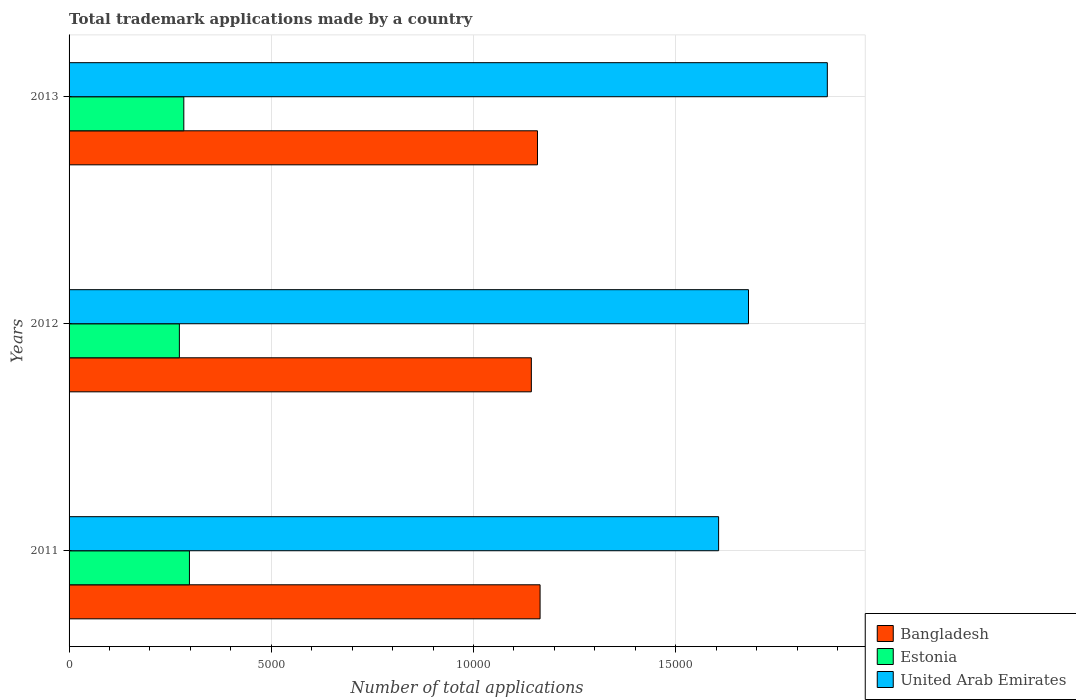How many different coloured bars are there?
Provide a succinct answer. 3. How many groups of bars are there?
Make the answer very short. 3. Are the number of bars on each tick of the Y-axis equal?
Offer a terse response. Yes. How many bars are there on the 3rd tick from the top?
Make the answer very short. 3. In how many cases, is the number of bars for a given year not equal to the number of legend labels?
Offer a very short reply. 0. What is the number of applications made by in Estonia in 2011?
Provide a succinct answer. 2976. Across all years, what is the maximum number of applications made by in Bangladesh?
Your answer should be very brief. 1.16e+04. Across all years, what is the minimum number of applications made by in United Arab Emirates?
Make the answer very short. 1.61e+04. In which year was the number of applications made by in United Arab Emirates maximum?
Your answer should be compact. 2013. In which year was the number of applications made by in Estonia minimum?
Provide a short and direct response. 2012. What is the total number of applications made by in Estonia in the graph?
Your response must be concise. 8540. What is the difference between the number of applications made by in Estonia in 2012 and that in 2013?
Provide a short and direct response. -110. What is the difference between the number of applications made by in United Arab Emirates in 2011 and the number of applications made by in Bangladesh in 2012?
Give a very brief answer. 4630. What is the average number of applications made by in Estonia per year?
Your answer should be very brief. 2846.67. In the year 2013, what is the difference between the number of applications made by in United Arab Emirates and number of applications made by in Estonia?
Offer a very short reply. 1.59e+04. What is the ratio of the number of applications made by in Estonia in 2012 to that in 2013?
Your answer should be very brief. 0.96. What is the difference between the highest and the second highest number of applications made by in Bangladesh?
Ensure brevity in your answer.  64. What is the difference between the highest and the lowest number of applications made by in United Arab Emirates?
Provide a succinct answer. 2688. In how many years, is the number of applications made by in Estonia greater than the average number of applications made by in Estonia taken over all years?
Provide a short and direct response. 1. How many bars are there?
Keep it short and to the point. 9. What is the difference between two consecutive major ticks on the X-axis?
Provide a succinct answer. 5000. Does the graph contain grids?
Give a very brief answer. Yes. How are the legend labels stacked?
Ensure brevity in your answer.  Vertical. What is the title of the graph?
Your answer should be compact. Total trademark applications made by a country. Does "Cabo Verde" appear as one of the legend labels in the graph?
Give a very brief answer. No. What is the label or title of the X-axis?
Ensure brevity in your answer.  Number of total applications. What is the label or title of the Y-axis?
Your answer should be very brief. Years. What is the Number of total applications of Bangladesh in 2011?
Ensure brevity in your answer.  1.16e+04. What is the Number of total applications of Estonia in 2011?
Give a very brief answer. 2976. What is the Number of total applications of United Arab Emirates in 2011?
Your answer should be compact. 1.61e+04. What is the Number of total applications in Bangladesh in 2012?
Offer a very short reply. 1.14e+04. What is the Number of total applications in Estonia in 2012?
Make the answer very short. 2727. What is the Number of total applications in United Arab Emirates in 2012?
Offer a very short reply. 1.68e+04. What is the Number of total applications in Bangladesh in 2013?
Your answer should be very brief. 1.16e+04. What is the Number of total applications of Estonia in 2013?
Provide a short and direct response. 2837. What is the Number of total applications of United Arab Emirates in 2013?
Your answer should be very brief. 1.87e+04. Across all years, what is the maximum Number of total applications in Bangladesh?
Give a very brief answer. 1.16e+04. Across all years, what is the maximum Number of total applications of Estonia?
Your answer should be very brief. 2976. Across all years, what is the maximum Number of total applications of United Arab Emirates?
Offer a very short reply. 1.87e+04. Across all years, what is the minimum Number of total applications in Bangladesh?
Offer a terse response. 1.14e+04. Across all years, what is the minimum Number of total applications in Estonia?
Provide a succinct answer. 2727. Across all years, what is the minimum Number of total applications of United Arab Emirates?
Your response must be concise. 1.61e+04. What is the total Number of total applications in Bangladesh in the graph?
Ensure brevity in your answer.  3.47e+04. What is the total Number of total applications in Estonia in the graph?
Provide a succinct answer. 8540. What is the total Number of total applications in United Arab Emirates in the graph?
Provide a short and direct response. 5.16e+04. What is the difference between the Number of total applications of Bangladesh in 2011 and that in 2012?
Make the answer very short. 216. What is the difference between the Number of total applications of Estonia in 2011 and that in 2012?
Make the answer very short. 249. What is the difference between the Number of total applications in United Arab Emirates in 2011 and that in 2012?
Offer a very short reply. -739. What is the difference between the Number of total applications in Bangladesh in 2011 and that in 2013?
Make the answer very short. 64. What is the difference between the Number of total applications of Estonia in 2011 and that in 2013?
Your answer should be compact. 139. What is the difference between the Number of total applications in United Arab Emirates in 2011 and that in 2013?
Ensure brevity in your answer.  -2688. What is the difference between the Number of total applications in Bangladesh in 2012 and that in 2013?
Provide a short and direct response. -152. What is the difference between the Number of total applications of Estonia in 2012 and that in 2013?
Keep it short and to the point. -110. What is the difference between the Number of total applications in United Arab Emirates in 2012 and that in 2013?
Offer a very short reply. -1949. What is the difference between the Number of total applications of Bangladesh in 2011 and the Number of total applications of Estonia in 2012?
Keep it short and to the point. 8918. What is the difference between the Number of total applications in Bangladesh in 2011 and the Number of total applications in United Arab Emirates in 2012?
Your response must be concise. -5153. What is the difference between the Number of total applications of Estonia in 2011 and the Number of total applications of United Arab Emirates in 2012?
Keep it short and to the point. -1.38e+04. What is the difference between the Number of total applications in Bangladesh in 2011 and the Number of total applications in Estonia in 2013?
Your response must be concise. 8808. What is the difference between the Number of total applications in Bangladesh in 2011 and the Number of total applications in United Arab Emirates in 2013?
Your answer should be very brief. -7102. What is the difference between the Number of total applications of Estonia in 2011 and the Number of total applications of United Arab Emirates in 2013?
Ensure brevity in your answer.  -1.58e+04. What is the difference between the Number of total applications of Bangladesh in 2012 and the Number of total applications of Estonia in 2013?
Offer a very short reply. 8592. What is the difference between the Number of total applications in Bangladesh in 2012 and the Number of total applications in United Arab Emirates in 2013?
Make the answer very short. -7318. What is the difference between the Number of total applications of Estonia in 2012 and the Number of total applications of United Arab Emirates in 2013?
Ensure brevity in your answer.  -1.60e+04. What is the average Number of total applications in Bangladesh per year?
Ensure brevity in your answer.  1.16e+04. What is the average Number of total applications in Estonia per year?
Offer a terse response. 2846.67. What is the average Number of total applications of United Arab Emirates per year?
Provide a short and direct response. 1.72e+04. In the year 2011, what is the difference between the Number of total applications in Bangladesh and Number of total applications in Estonia?
Keep it short and to the point. 8669. In the year 2011, what is the difference between the Number of total applications of Bangladesh and Number of total applications of United Arab Emirates?
Your response must be concise. -4414. In the year 2011, what is the difference between the Number of total applications of Estonia and Number of total applications of United Arab Emirates?
Make the answer very short. -1.31e+04. In the year 2012, what is the difference between the Number of total applications of Bangladesh and Number of total applications of Estonia?
Offer a terse response. 8702. In the year 2012, what is the difference between the Number of total applications in Bangladesh and Number of total applications in United Arab Emirates?
Your response must be concise. -5369. In the year 2012, what is the difference between the Number of total applications in Estonia and Number of total applications in United Arab Emirates?
Provide a succinct answer. -1.41e+04. In the year 2013, what is the difference between the Number of total applications of Bangladesh and Number of total applications of Estonia?
Keep it short and to the point. 8744. In the year 2013, what is the difference between the Number of total applications of Bangladesh and Number of total applications of United Arab Emirates?
Provide a succinct answer. -7166. In the year 2013, what is the difference between the Number of total applications in Estonia and Number of total applications in United Arab Emirates?
Keep it short and to the point. -1.59e+04. What is the ratio of the Number of total applications of Bangladesh in 2011 to that in 2012?
Your answer should be very brief. 1.02. What is the ratio of the Number of total applications of Estonia in 2011 to that in 2012?
Provide a succinct answer. 1.09. What is the ratio of the Number of total applications of United Arab Emirates in 2011 to that in 2012?
Ensure brevity in your answer.  0.96. What is the ratio of the Number of total applications in Bangladesh in 2011 to that in 2013?
Your response must be concise. 1.01. What is the ratio of the Number of total applications of Estonia in 2011 to that in 2013?
Make the answer very short. 1.05. What is the ratio of the Number of total applications in United Arab Emirates in 2011 to that in 2013?
Keep it short and to the point. 0.86. What is the ratio of the Number of total applications of Bangladesh in 2012 to that in 2013?
Provide a succinct answer. 0.99. What is the ratio of the Number of total applications of Estonia in 2012 to that in 2013?
Make the answer very short. 0.96. What is the ratio of the Number of total applications of United Arab Emirates in 2012 to that in 2013?
Offer a very short reply. 0.9. What is the difference between the highest and the second highest Number of total applications in Bangladesh?
Your answer should be very brief. 64. What is the difference between the highest and the second highest Number of total applications of Estonia?
Ensure brevity in your answer.  139. What is the difference between the highest and the second highest Number of total applications in United Arab Emirates?
Give a very brief answer. 1949. What is the difference between the highest and the lowest Number of total applications of Bangladesh?
Offer a terse response. 216. What is the difference between the highest and the lowest Number of total applications of Estonia?
Provide a short and direct response. 249. What is the difference between the highest and the lowest Number of total applications of United Arab Emirates?
Ensure brevity in your answer.  2688. 